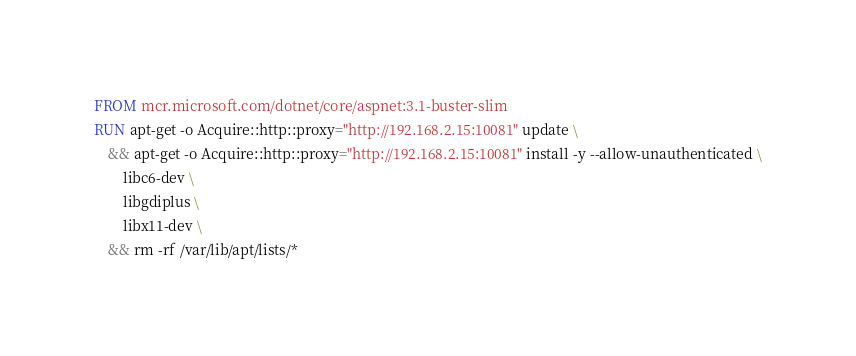<code> <loc_0><loc_0><loc_500><loc_500><_Dockerfile_>FROM mcr.microsoft.com/dotnet/core/aspnet:3.1-buster-slim
RUN apt-get -o Acquire::http::proxy="http://192.168.2.15:10081" update \
    && apt-get -o Acquire::http::proxy="http://192.168.2.15:10081" install -y --allow-unauthenticated \
        libc6-dev \
        libgdiplus \
        libx11-dev \
    && rm -rf /var/lib/apt/lists/*</code> 